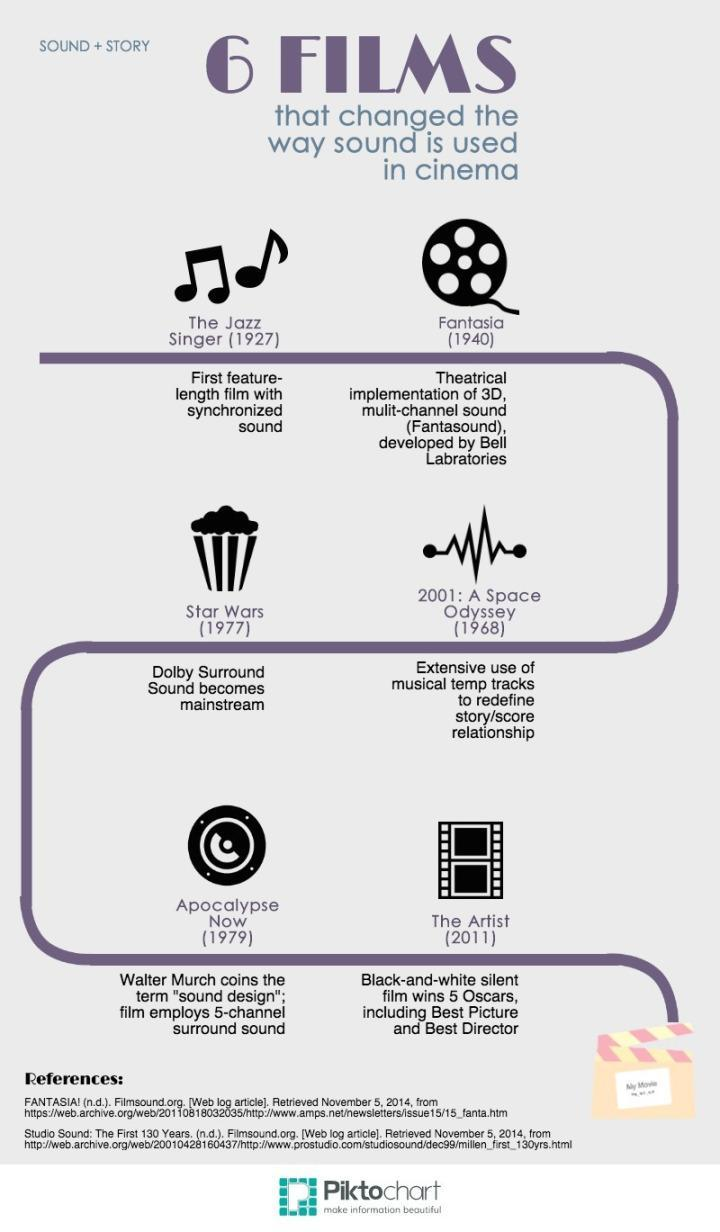When was the movie 'Fantasia' released?
Answer the question with a short phrase. 1940 When was the movie 'The Artist' released? (2011) Which film released in 1977 used the dolby sound effects? Star Wars Which was the first feature length film released with synchronized sound? The Jazz Singer 